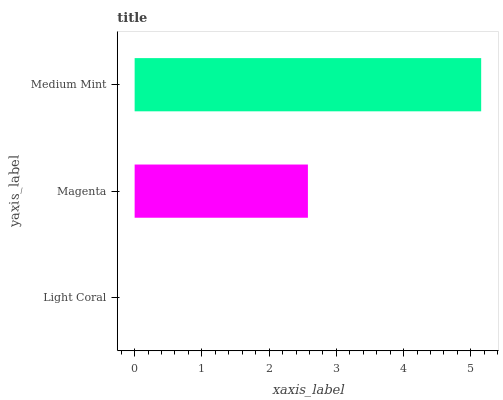Is Light Coral the minimum?
Answer yes or no. Yes. Is Medium Mint the maximum?
Answer yes or no. Yes. Is Magenta the minimum?
Answer yes or no. No. Is Magenta the maximum?
Answer yes or no. No. Is Magenta greater than Light Coral?
Answer yes or no. Yes. Is Light Coral less than Magenta?
Answer yes or no. Yes. Is Light Coral greater than Magenta?
Answer yes or no. No. Is Magenta less than Light Coral?
Answer yes or no. No. Is Magenta the high median?
Answer yes or no. Yes. Is Magenta the low median?
Answer yes or no. Yes. Is Medium Mint the high median?
Answer yes or no. No. Is Light Coral the low median?
Answer yes or no. No. 